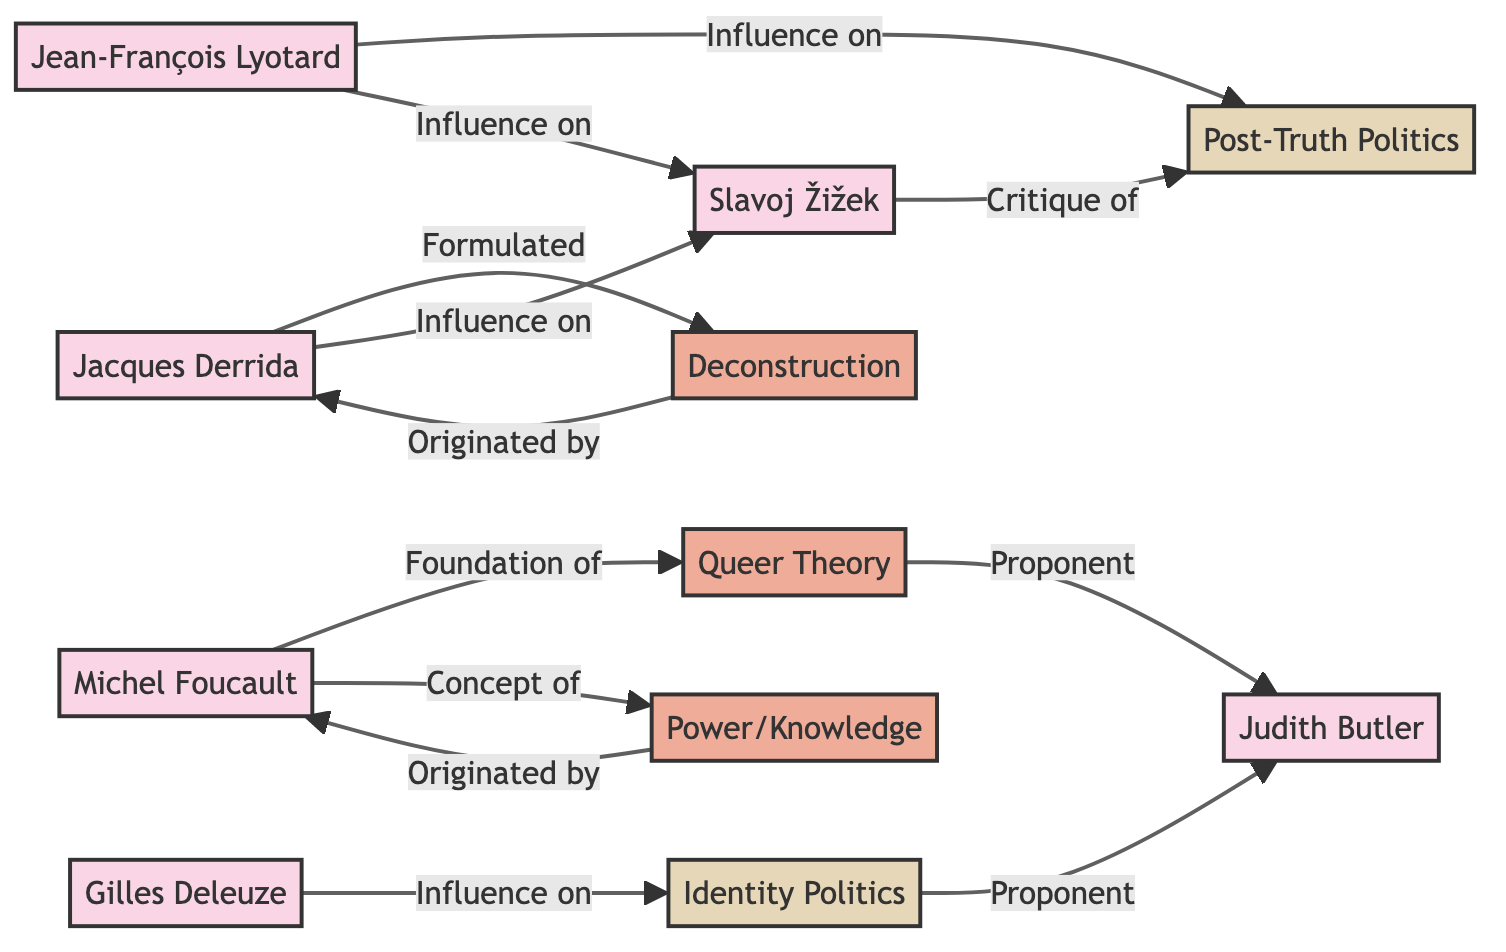What's the total number of philosophers in the diagram? The diagram lists six distinct philosophers: Jean-François Lyotard, Michel Foucault, Jacques Derrida, Gilles Deleuze, Judith Butler, and Slavoj Žižek. By counting these nodes, we determine the total number of philosophers.
Answer: 6 Which philosopher formulated the concept of deconstruction? The diagram explicitly connects Jacques Derrida with the concept of deconstruction labeled as "Formulated." Thus, Jacques Derrida is the philosopher associated with the formulation of this concept.
Answer: Jacques Derrida What movements are influenced by Jean-François Lyotard? The diagram shows two arrows indicating the influence of Jean-François Lyotard on Post-Truth Politics and Slavoj Žižek. By tracing the edges leading from Lyotard's node to the corresponding movements, we can identify these influences.
Answer: Post-Truth Politics, Slavoj Žižek Who is a proponent of Queer Theory according to the diagram? The diagram connects the concept of Queer Theory to Judith Butler through an arrow labeled "Proponent." This establishes Judith Butler as the figure advocating for this theory within the diagram.
Answer: Judith Butler What is the relationship between Michel Foucault and the concept of power/knowledge? The diagram indicates that Michel Foucault is the originator of the concept of power/knowledge, as shown by the arrow labeled "Originated by." Thus, Foucault's relationship to this concept is as its originator.
Answer: Originated by Michel Foucault How many movements are depicted in the diagram? The diagram categorizes two movements: Post-Truth Politics and Identity Politics. By identifying and counting these nodes labeled as movements, we can ascertain the total number of movements present.
Answer: 2 What is the common influence of Jacques Derrida on other philosophers? The diagram indicates that Jacques Derrida influences both Slavoj Žižek and Michel Foucault with arrows labeled "Influence on." This illustrates the role of Derrida in shaping the perspectives of these philosophers.
Answer: Slavoj Žižek, Michel Foucault Which concept is associated with the philosopher Gilles Deleuze? The diagram shows an arrow indicating that Gilles Deleuze has an influence on the movement of Identity Politics. This establishes a connection between Deleuze and the concept represented by that movement.
Answer: Identity Politics What do Judith Butler and Queer Theory have in common according to the diagram? The diagram demonstrates that Judith Butler is a proponent of Queer Theory, illustrated by an arrow labeled "Proponent." This connection indicates Butler’s supportive role in advancing this theoretical framework.
Answer: Proponent of Queer Theory 